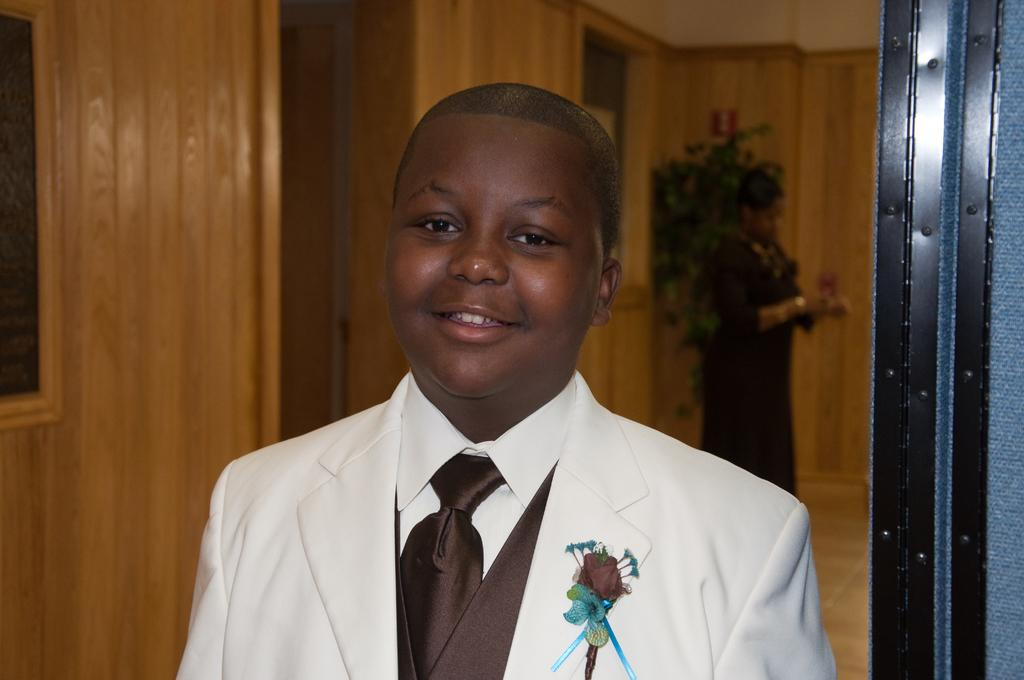Who is present in the image? There is a person in the image. What is the person doing in the image? The person is smiling. What is the person wearing in the image? The person is wearing a suit. Can you describe the background of the image? There is another person standing in the background of the image, and there is a wall visible in the background. What word is the person saying in the image? There is no indication in the image of what the person might be saying, so it cannot be determined from the picture. 